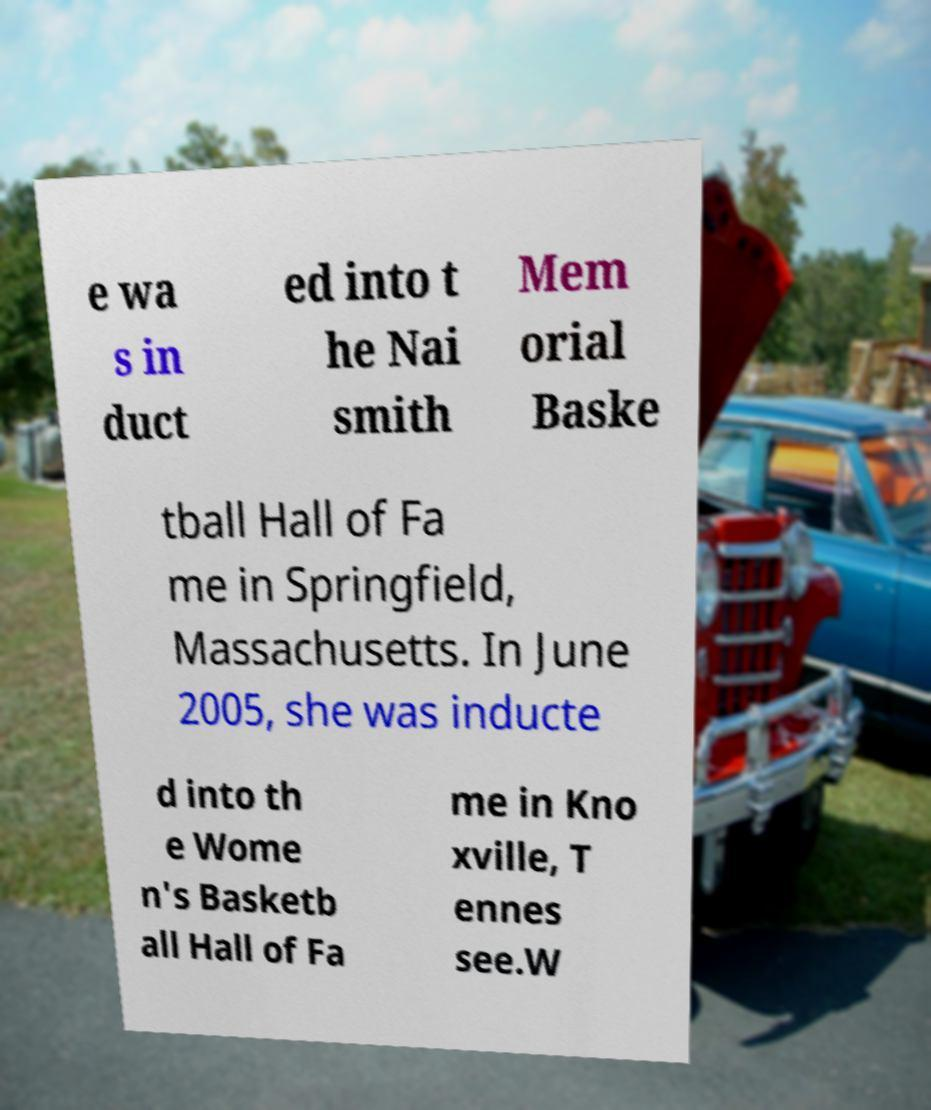I need the written content from this picture converted into text. Can you do that? e wa s in duct ed into t he Nai smith Mem orial Baske tball Hall of Fa me in Springfield, Massachusetts. In June 2005, she was inducte d into th e Wome n's Basketb all Hall of Fa me in Kno xville, T ennes see.W 